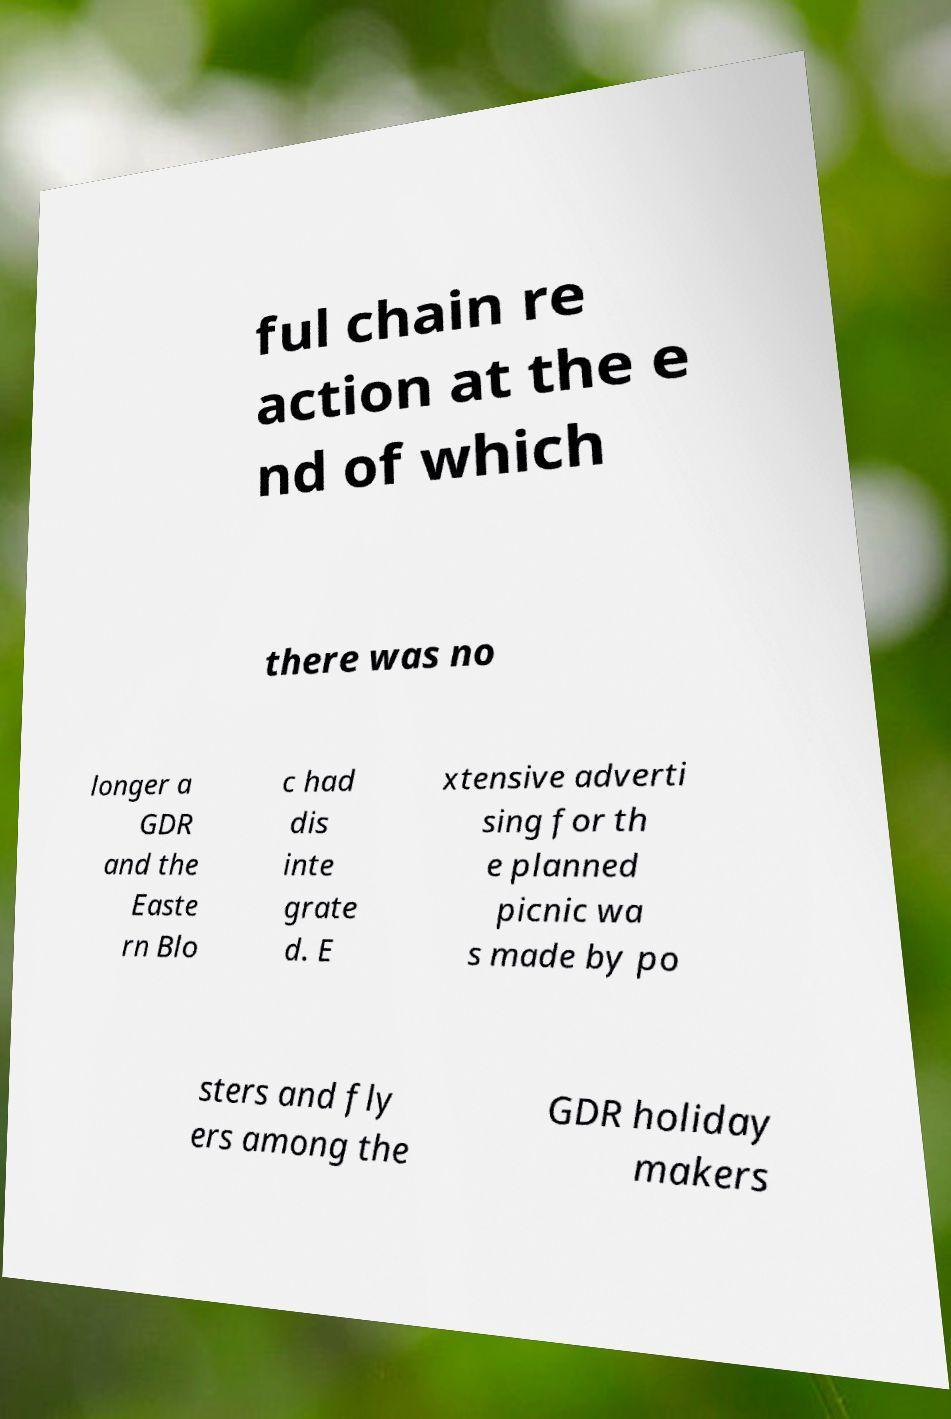Could you assist in decoding the text presented in this image and type it out clearly? ful chain re action at the e nd of which there was no longer a GDR and the Easte rn Blo c had dis inte grate d. E xtensive adverti sing for th e planned picnic wa s made by po sters and fly ers among the GDR holiday makers 